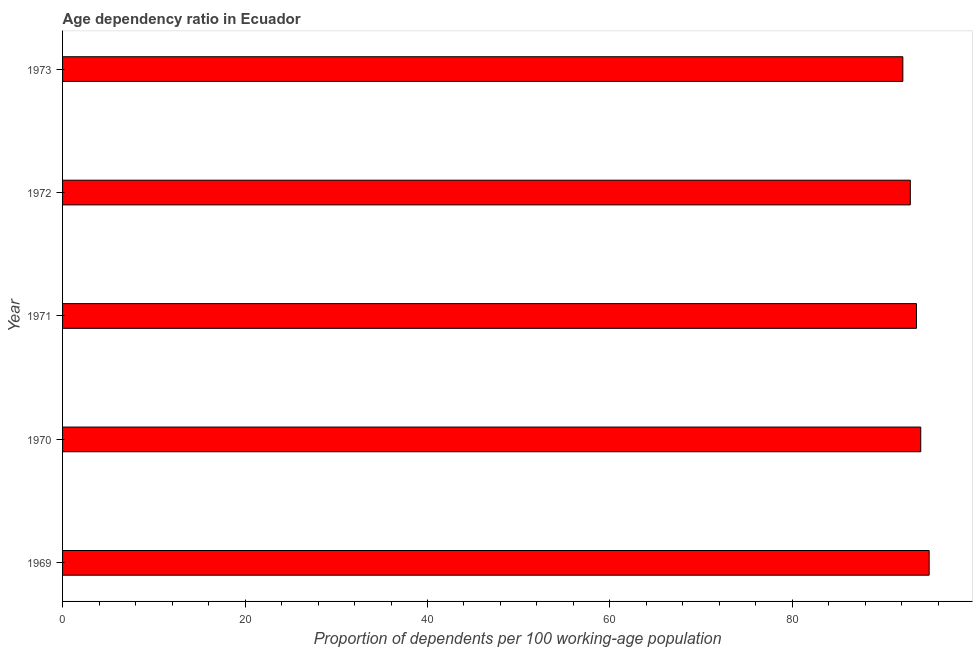Does the graph contain any zero values?
Provide a succinct answer. No. What is the title of the graph?
Give a very brief answer. Age dependency ratio in Ecuador. What is the label or title of the X-axis?
Offer a very short reply. Proportion of dependents per 100 working-age population. What is the label or title of the Y-axis?
Provide a succinct answer. Year. What is the age dependency ratio in 1970?
Offer a very short reply. 94.07. Across all years, what is the maximum age dependency ratio?
Make the answer very short. 94.99. Across all years, what is the minimum age dependency ratio?
Your answer should be very brief. 92.11. In which year was the age dependency ratio maximum?
Give a very brief answer. 1969. What is the sum of the age dependency ratio?
Ensure brevity in your answer.  467.69. What is the difference between the age dependency ratio in 1970 and 1973?
Ensure brevity in your answer.  1.96. What is the average age dependency ratio per year?
Keep it short and to the point. 93.54. What is the median age dependency ratio?
Offer a very short reply. 93.6. In how many years, is the age dependency ratio greater than 56 ?
Your response must be concise. 5. What is the ratio of the age dependency ratio in 1970 to that in 1973?
Provide a succinct answer. 1.02. Is the difference between the age dependency ratio in 1969 and 1970 greater than the difference between any two years?
Ensure brevity in your answer.  No. What is the difference between the highest and the second highest age dependency ratio?
Your response must be concise. 0.92. What is the difference between the highest and the lowest age dependency ratio?
Your answer should be very brief. 2.88. In how many years, is the age dependency ratio greater than the average age dependency ratio taken over all years?
Offer a very short reply. 3. How many bars are there?
Your answer should be compact. 5. How many years are there in the graph?
Give a very brief answer. 5. Are the values on the major ticks of X-axis written in scientific E-notation?
Provide a short and direct response. No. What is the Proportion of dependents per 100 working-age population in 1969?
Offer a terse response. 94.99. What is the Proportion of dependents per 100 working-age population of 1970?
Give a very brief answer. 94.07. What is the Proportion of dependents per 100 working-age population of 1971?
Your response must be concise. 93.6. What is the Proportion of dependents per 100 working-age population of 1972?
Your response must be concise. 92.92. What is the Proportion of dependents per 100 working-age population in 1973?
Your answer should be compact. 92.11. What is the difference between the Proportion of dependents per 100 working-age population in 1969 and 1970?
Your response must be concise. 0.92. What is the difference between the Proportion of dependents per 100 working-age population in 1969 and 1971?
Ensure brevity in your answer.  1.39. What is the difference between the Proportion of dependents per 100 working-age population in 1969 and 1972?
Your answer should be very brief. 2.07. What is the difference between the Proportion of dependents per 100 working-age population in 1969 and 1973?
Your response must be concise. 2.88. What is the difference between the Proportion of dependents per 100 working-age population in 1970 and 1971?
Your answer should be compact. 0.47. What is the difference between the Proportion of dependents per 100 working-age population in 1970 and 1972?
Give a very brief answer. 1.14. What is the difference between the Proportion of dependents per 100 working-age population in 1970 and 1973?
Give a very brief answer. 1.96. What is the difference between the Proportion of dependents per 100 working-age population in 1971 and 1972?
Provide a succinct answer. 0.68. What is the difference between the Proportion of dependents per 100 working-age population in 1971 and 1973?
Ensure brevity in your answer.  1.5. What is the difference between the Proportion of dependents per 100 working-age population in 1972 and 1973?
Offer a terse response. 0.82. What is the ratio of the Proportion of dependents per 100 working-age population in 1969 to that in 1971?
Make the answer very short. 1.01. What is the ratio of the Proportion of dependents per 100 working-age population in 1969 to that in 1972?
Ensure brevity in your answer.  1.02. What is the ratio of the Proportion of dependents per 100 working-age population in 1969 to that in 1973?
Offer a very short reply. 1.03. What is the ratio of the Proportion of dependents per 100 working-age population in 1970 to that in 1971?
Your answer should be very brief. 1. What is the ratio of the Proportion of dependents per 100 working-age population in 1970 to that in 1972?
Provide a short and direct response. 1.01. What is the ratio of the Proportion of dependents per 100 working-age population in 1971 to that in 1973?
Provide a short and direct response. 1.02. What is the ratio of the Proportion of dependents per 100 working-age population in 1972 to that in 1973?
Your response must be concise. 1.01. 